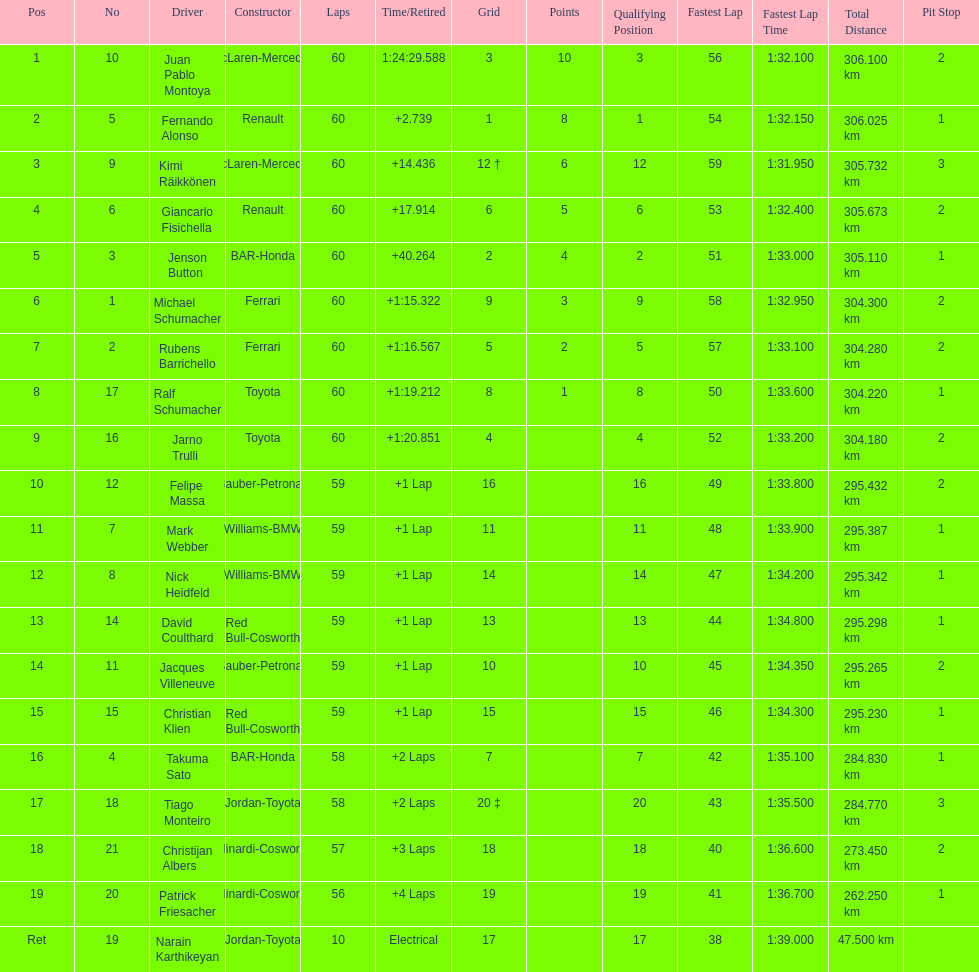How many toyota's are there on the list? 4. 